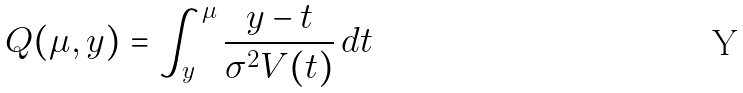<formula> <loc_0><loc_0><loc_500><loc_500>Q ( \mu , y ) = \int _ { y } ^ { \mu } \frac { y - t } { \sigma ^ { 2 } V ( t ) } \, d t</formula> 